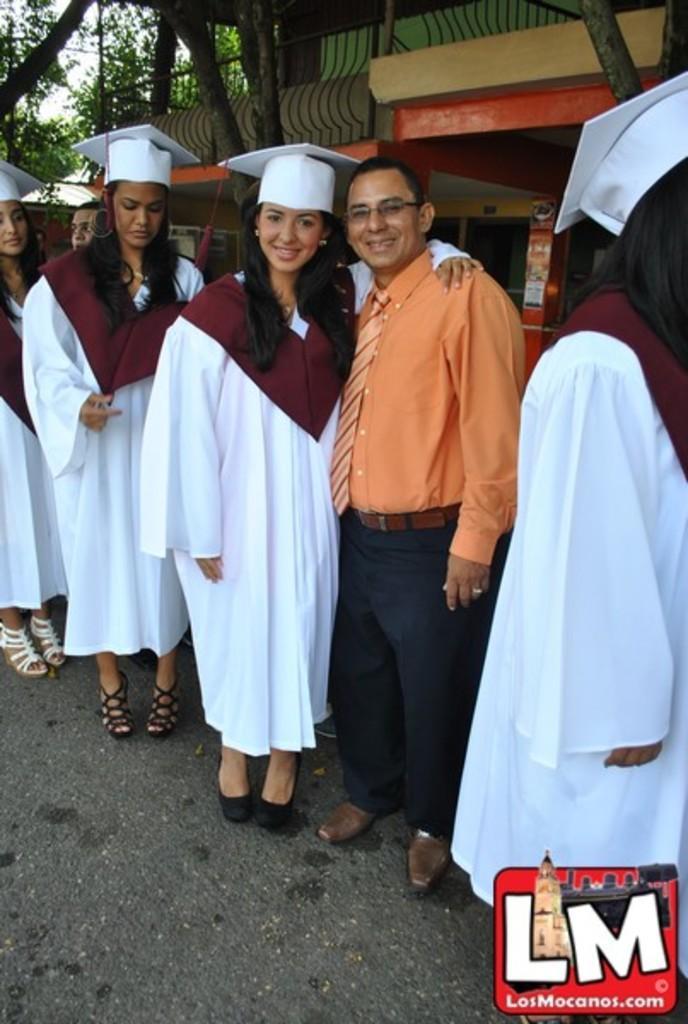How would you summarize this image in a sentence or two? In the image few people are standing and smiling. Behind them there is a building and there are some trees. 